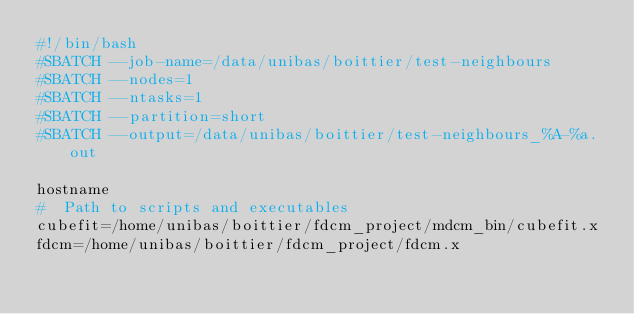<code> <loc_0><loc_0><loc_500><loc_500><_Bash_>#!/bin/bash
#SBATCH --job-name=/data/unibas/boittier/test-neighbours
#SBATCH --nodes=1
#SBATCH --ntasks=1
#SBATCH --partition=short
#SBATCH --output=/data/unibas/boittier/test-neighbours_%A-%a.out

hostname
#  Path to scripts and executables
cubefit=/home/unibas/boittier/fdcm_project/mdcm_bin/cubefit.x
fdcm=/home/unibas/boittier/fdcm_project/fdcm.x</code> 